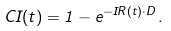<formula> <loc_0><loc_0><loc_500><loc_500>C I ( t ) = 1 - e ^ { - I R ( t ) \cdot D } \, .</formula> 